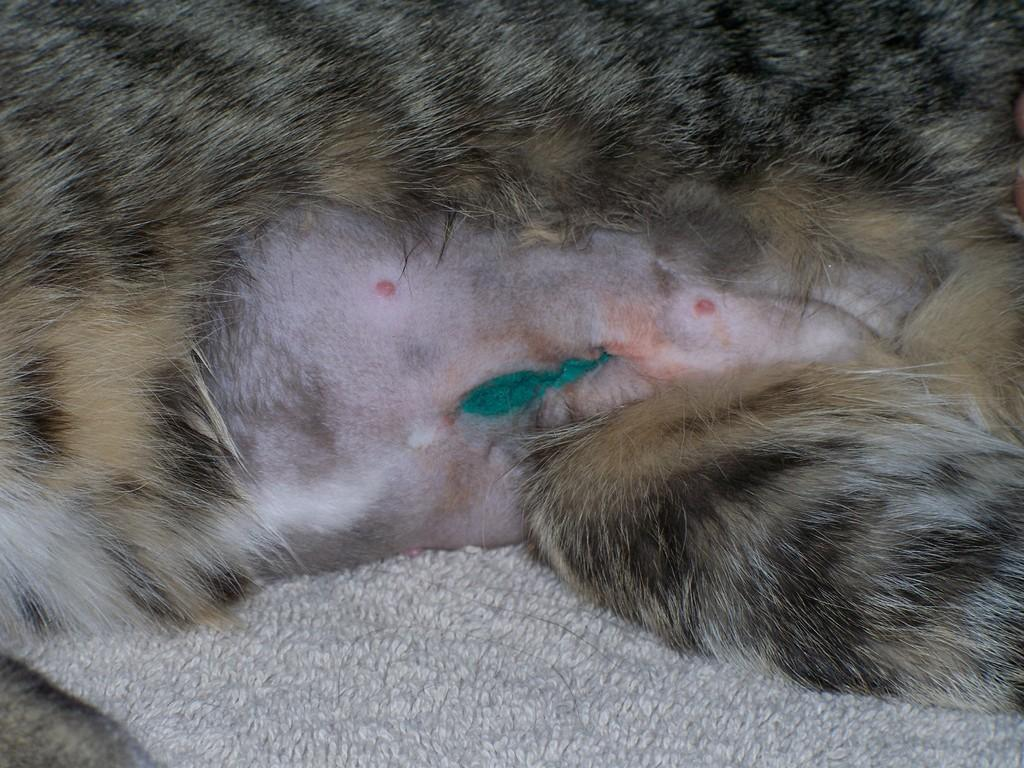What type of creature is present in the image? There is an animal in the image. What is the animal doing in the image? The animal is sitting on an object. What type of thrill does the animal experience while sitting on the object in the image? There is no indication of the animal experiencing any thrill in the image. 